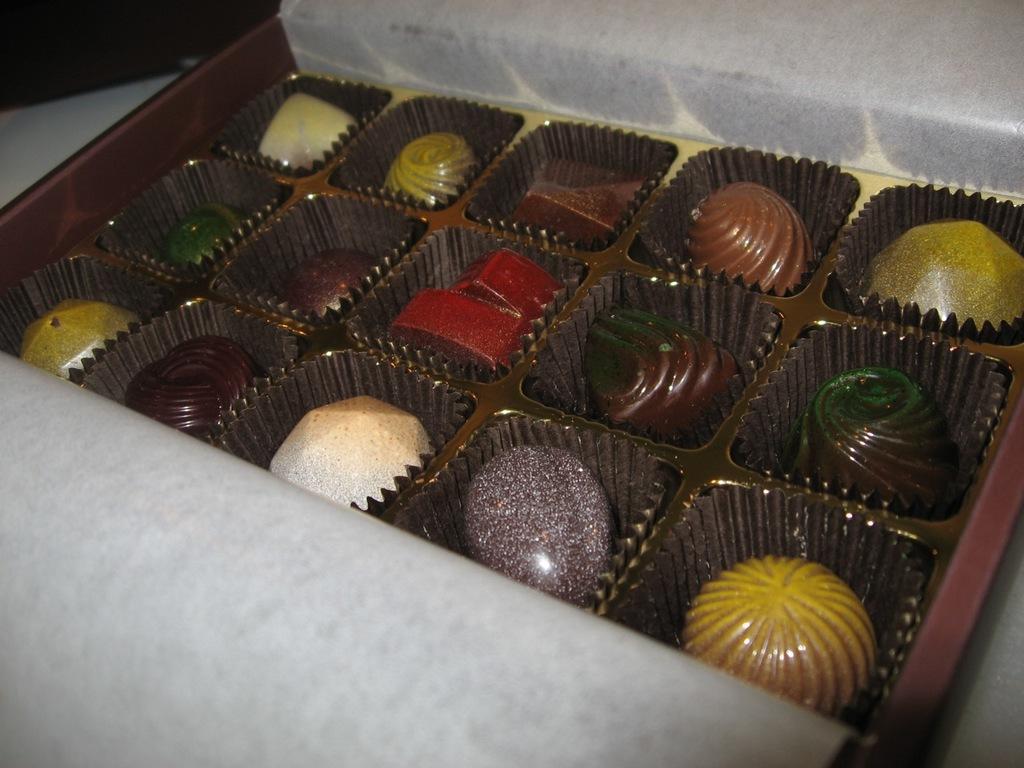Can you describe this image briefly? In this image, we can see chocolates in the tray. 